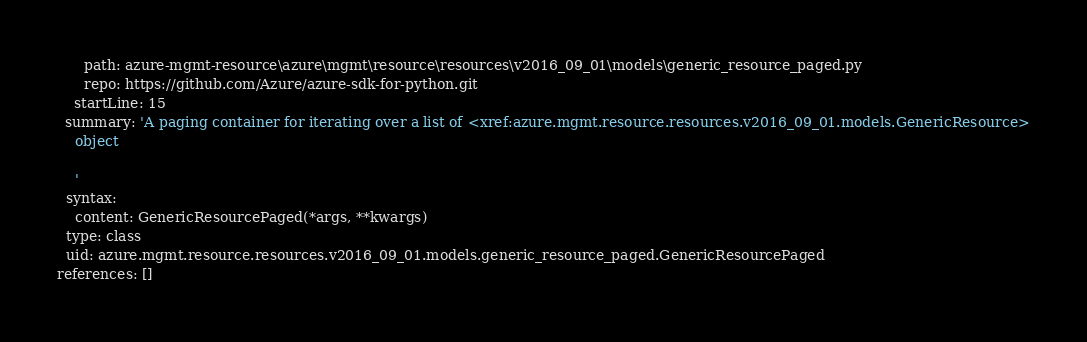Convert code to text. <code><loc_0><loc_0><loc_500><loc_500><_YAML_>      path: azure-mgmt-resource\azure\mgmt\resource\resources\v2016_09_01\models\generic_resource_paged.py
      repo: https://github.com/Azure/azure-sdk-for-python.git
    startLine: 15
  summary: 'A paging container for iterating over a list of <xref:azure.mgmt.resource.resources.v2016_09_01.models.GenericResource>
    object

    '
  syntax:
    content: GenericResourcePaged(*args, **kwargs)
  type: class
  uid: azure.mgmt.resource.resources.v2016_09_01.models.generic_resource_paged.GenericResourcePaged
references: []
</code> 